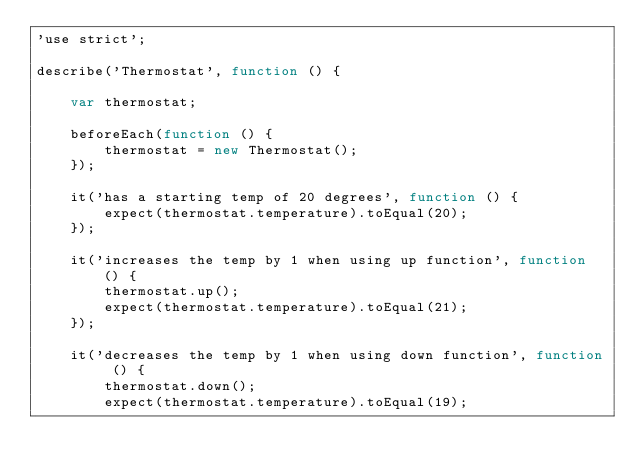<code> <loc_0><loc_0><loc_500><loc_500><_JavaScript_>'use strict';

describe('Thermostat', function () {

    var thermostat;

    beforeEach(function () {
        thermostat = new Thermostat();
    });

    it('has a starting temp of 20 degrees', function () {
        expect(thermostat.temperature).toEqual(20);
    });

    it('increases the temp by 1 when using up function', function () {
        thermostat.up();
        expect(thermostat.temperature).toEqual(21);
    });

    it('decreases the temp by 1 when using down function', function () {
        thermostat.down();
        expect(thermostat.temperature).toEqual(19);</code> 